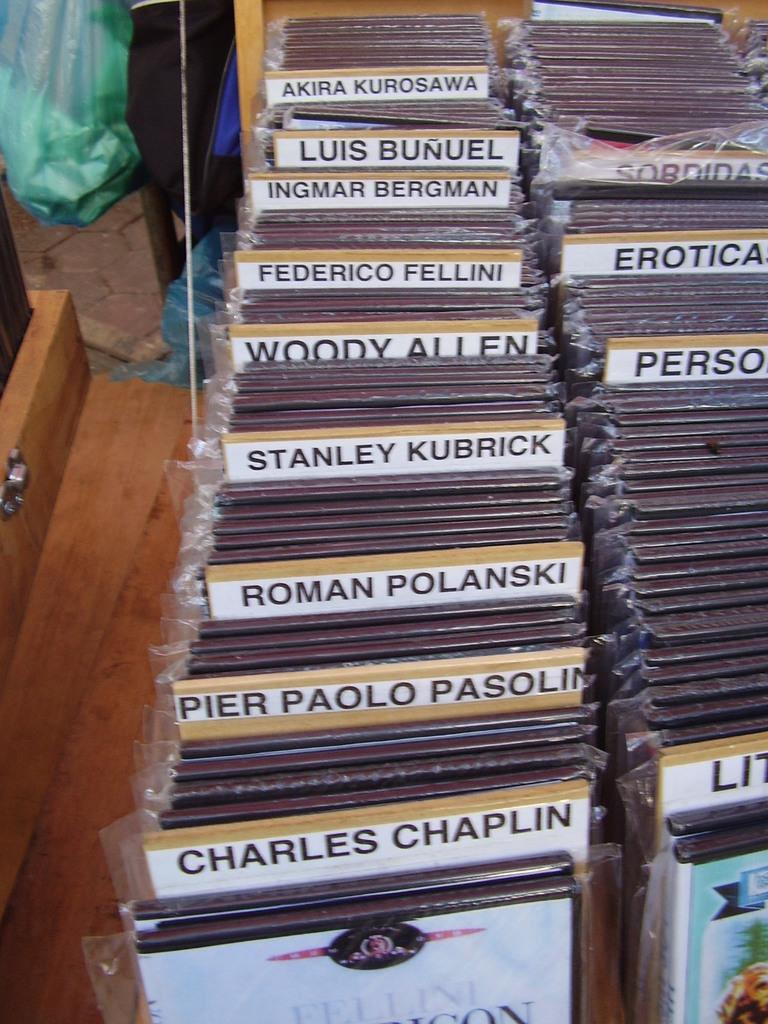<image>
Offer a succinct explanation of the picture presented. A large collection of DVDs from the likes of Woody Allen, Roman Polanski, Ingmar Bergman, and Charles Chaplin. 